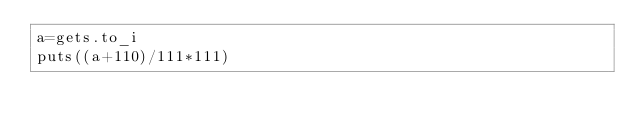<code> <loc_0><loc_0><loc_500><loc_500><_Ruby_>a=gets.to_i
puts((a+110)/111*111)</code> 